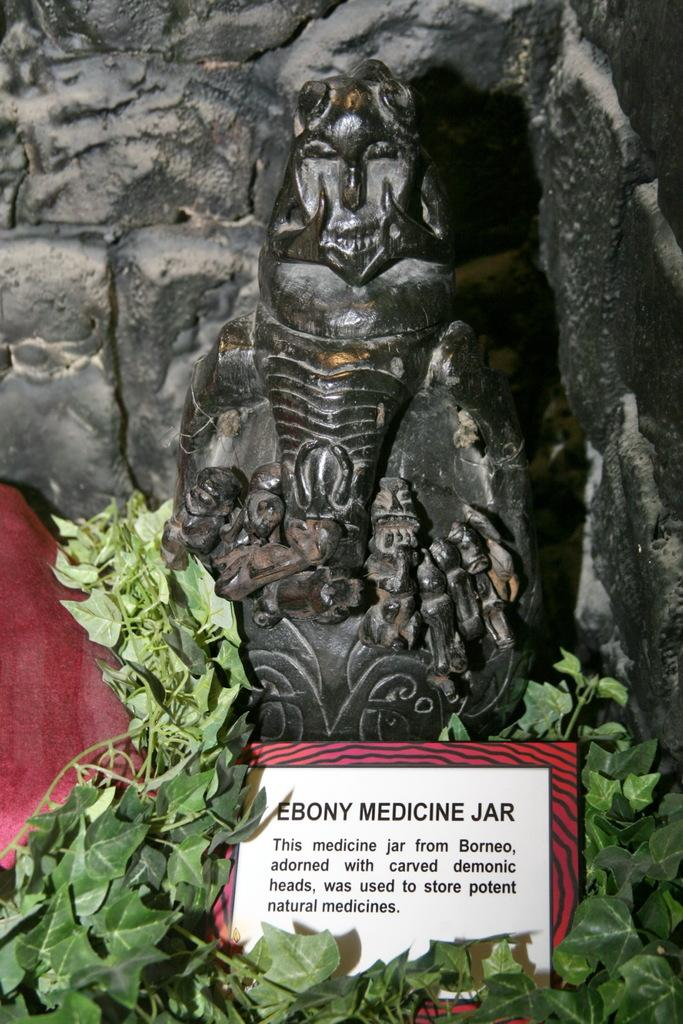What is the main subject in the image? There is a statue in the image. Are there any other objects or elements in the image besides the statue? Yes, there is a plant and a board are also present in the image. What type of cork can be seen on the mountain in the image? There is no mountain or cork present in the image; the image only contains a statue, a plant, and a board. 